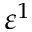<formula> <loc_0><loc_0><loc_500><loc_500>\varepsilon ^ { 1 }</formula> 